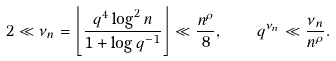Convert formula to latex. <formula><loc_0><loc_0><loc_500><loc_500>2 \ll \nu _ { n } = \left \lfloor \frac { q ^ { 4 } \log ^ { 2 } n } { 1 + \log q ^ { - 1 } } \right \rfloor \ll \frac { n ^ { \rho } } { 8 } , \quad q ^ { \nu _ { n } } \ll \frac { \nu _ { n } } { n ^ { \rho } } .</formula> 